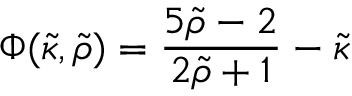Convert formula to latex. <formula><loc_0><loc_0><loc_500><loc_500>\Phi ( { \tilde { \kappa } } , { \tilde { \rho } } ) = { \frac { 5 { \tilde { \rho } } - 2 } { 2 { \tilde { \rho } } + 1 } } - { \tilde { \kappa } }</formula> 